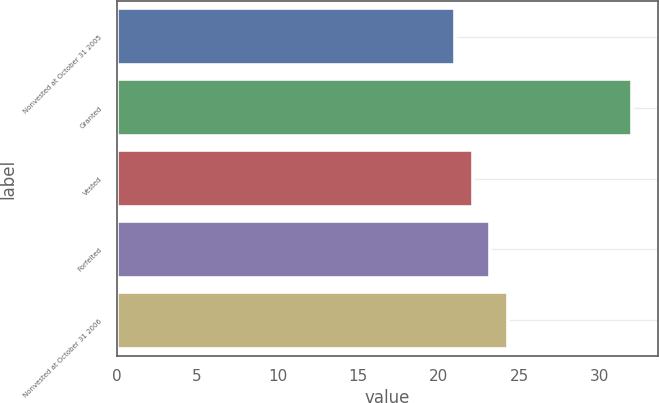Convert chart. <chart><loc_0><loc_0><loc_500><loc_500><bar_chart><fcel>Nonvested at October 31 2005<fcel>Granted<fcel>Vested<fcel>Forfeited<fcel>Nonvested at October 31 2006<nl><fcel>21<fcel>32<fcel>22.1<fcel>23.2<fcel>24.3<nl></chart> 